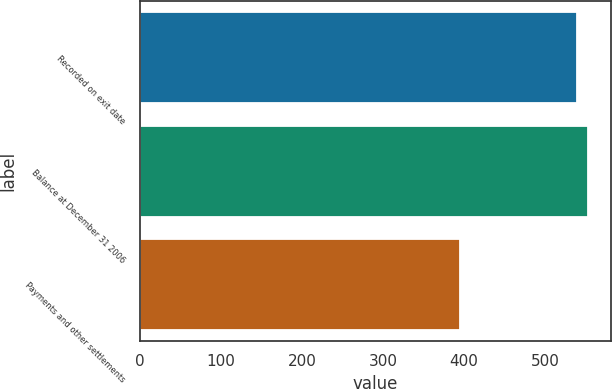<chart> <loc_0><loc_0><loc_500><loc_500><bar_chart><fcel>Recorded on exit date<fcel>Balance at December 31 2006<fcel>Payments and other settlements<nl><fcel>539<fcel>553.4<fcel>395<nl></chart> 